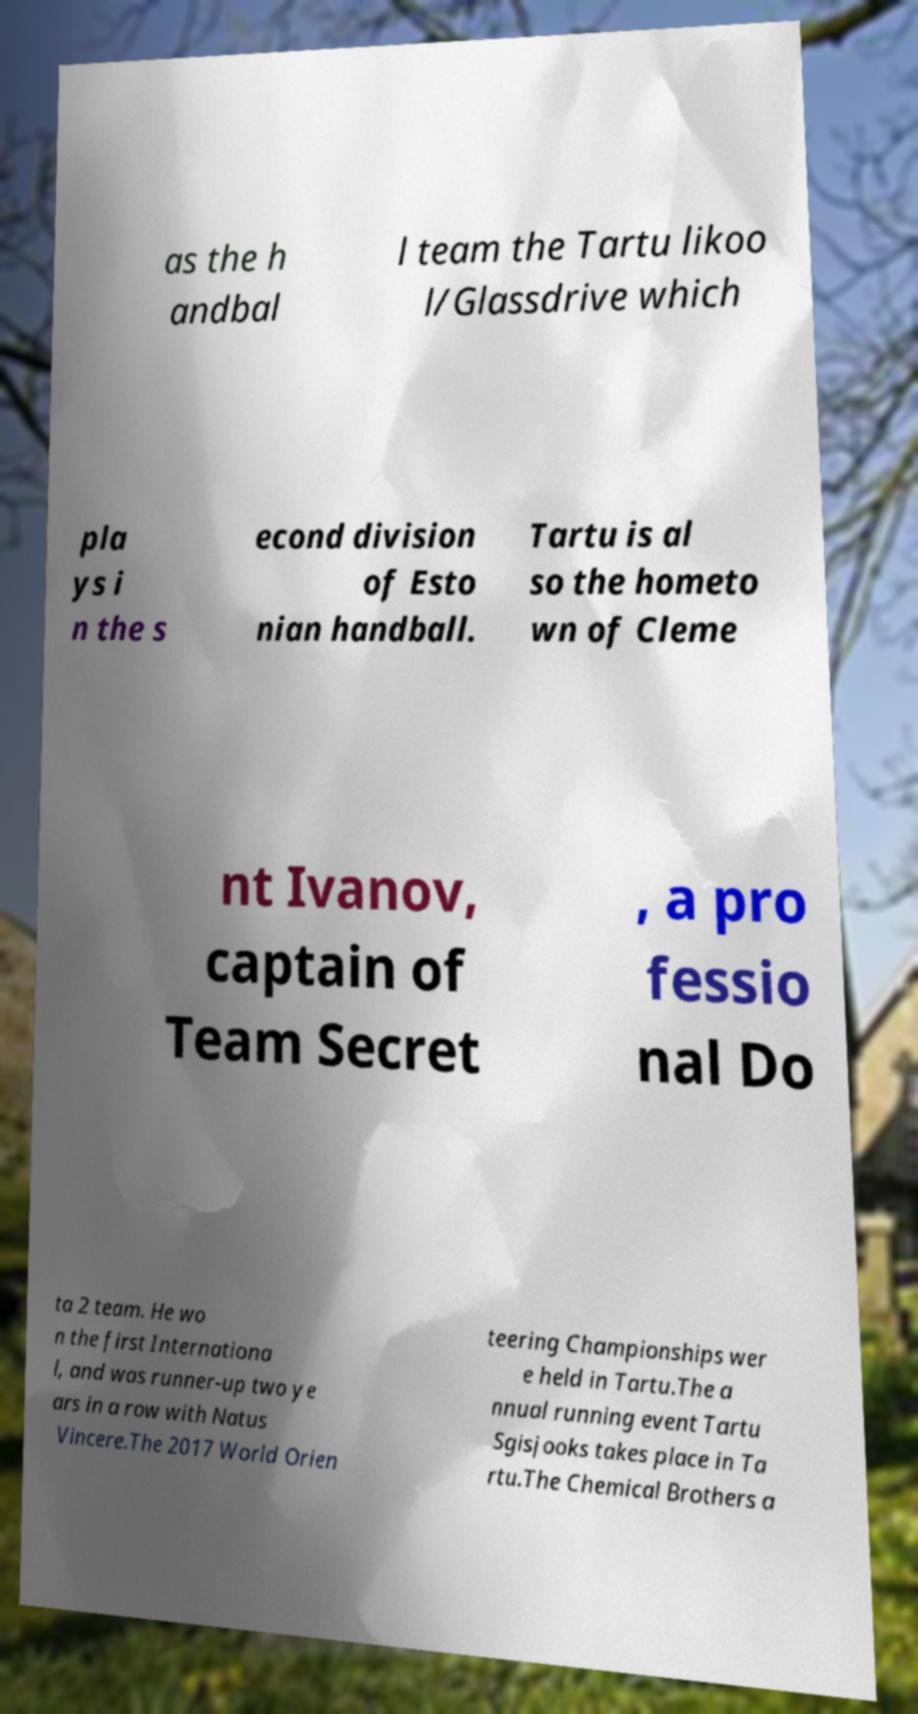Can you accurately transcribe the text from the provided image for me? as the h andbal l team the Tartu likoo l/Glassdrive which pla ys i n the s econd division of Esto nian handball. Tartu is al so the hometo wn of Cleme nt Ivanov, captain of Team Secret , a pro fessio nal Do ta 2 team. He wo n the first Internationa l, and was runner-up two ye ars in a row with Natus Vincere.The 2017 World Orien teering Championships wer e held in Tartu.The a nnual running event Tartu Sgisjooks takes place in Ta rtu.The Chemical Brothers a 